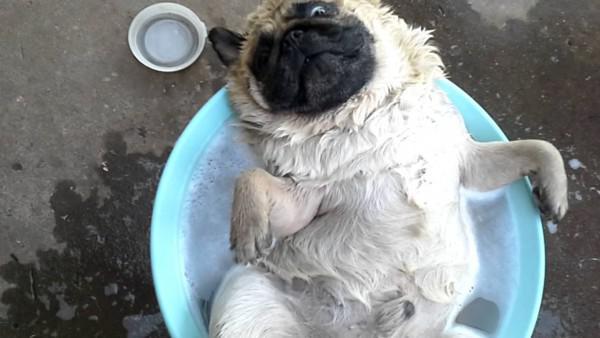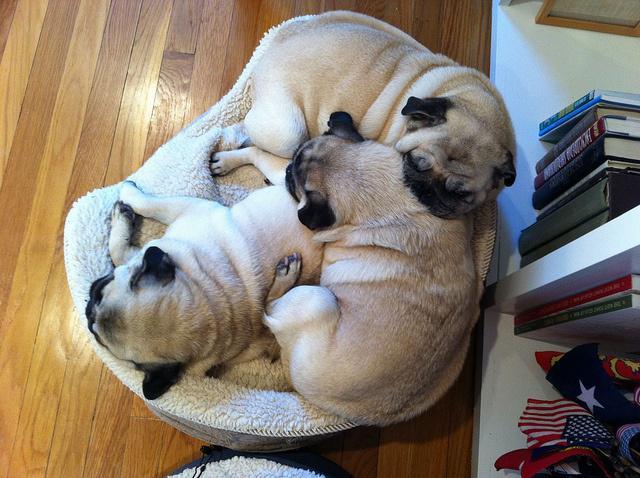The first image is the image on the left, the second image is the image on the right. Assess this claim about the two images: "a pug is dressed in a costime". Correct or not? Answer yes or no. No. The first image is the image on the left, the second image is the image on the right. Evaluate the accuracy of this statement regarding the images: "One of the dogs is dressed in a costume and the other dog's head is hanging out of a backpack.". Is it true? Answer yes or no. No. 